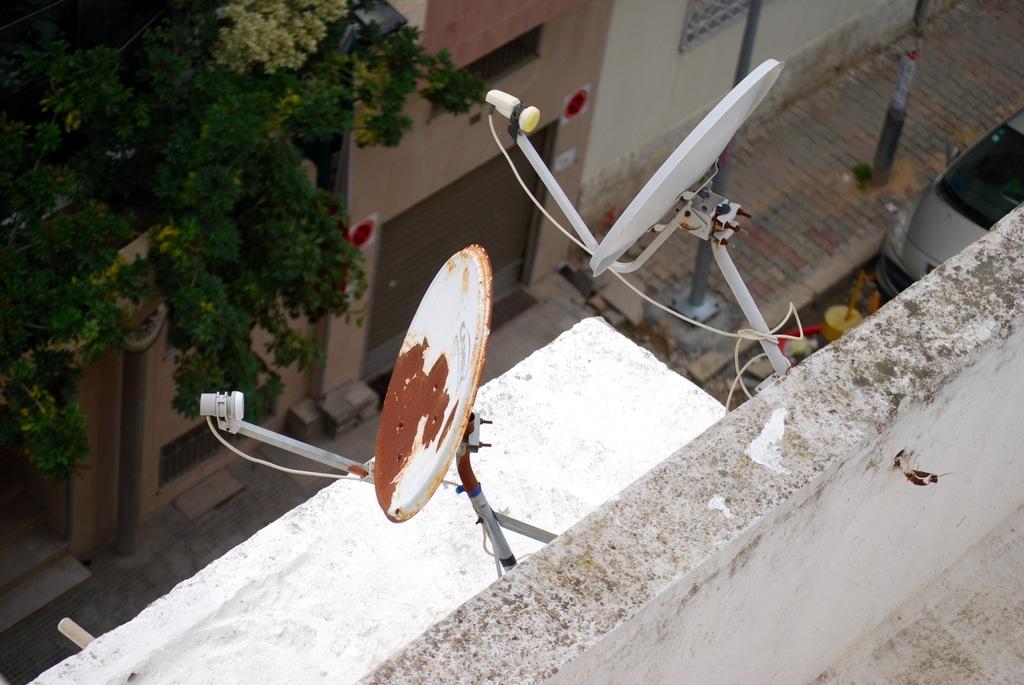How would you summarize this image in a sentence or two? In this image I can see two dishes attached to the wall. The wall is in white color. Back I can see a buildings,windows and a trees. I can see a poles and vehicle on the road. 